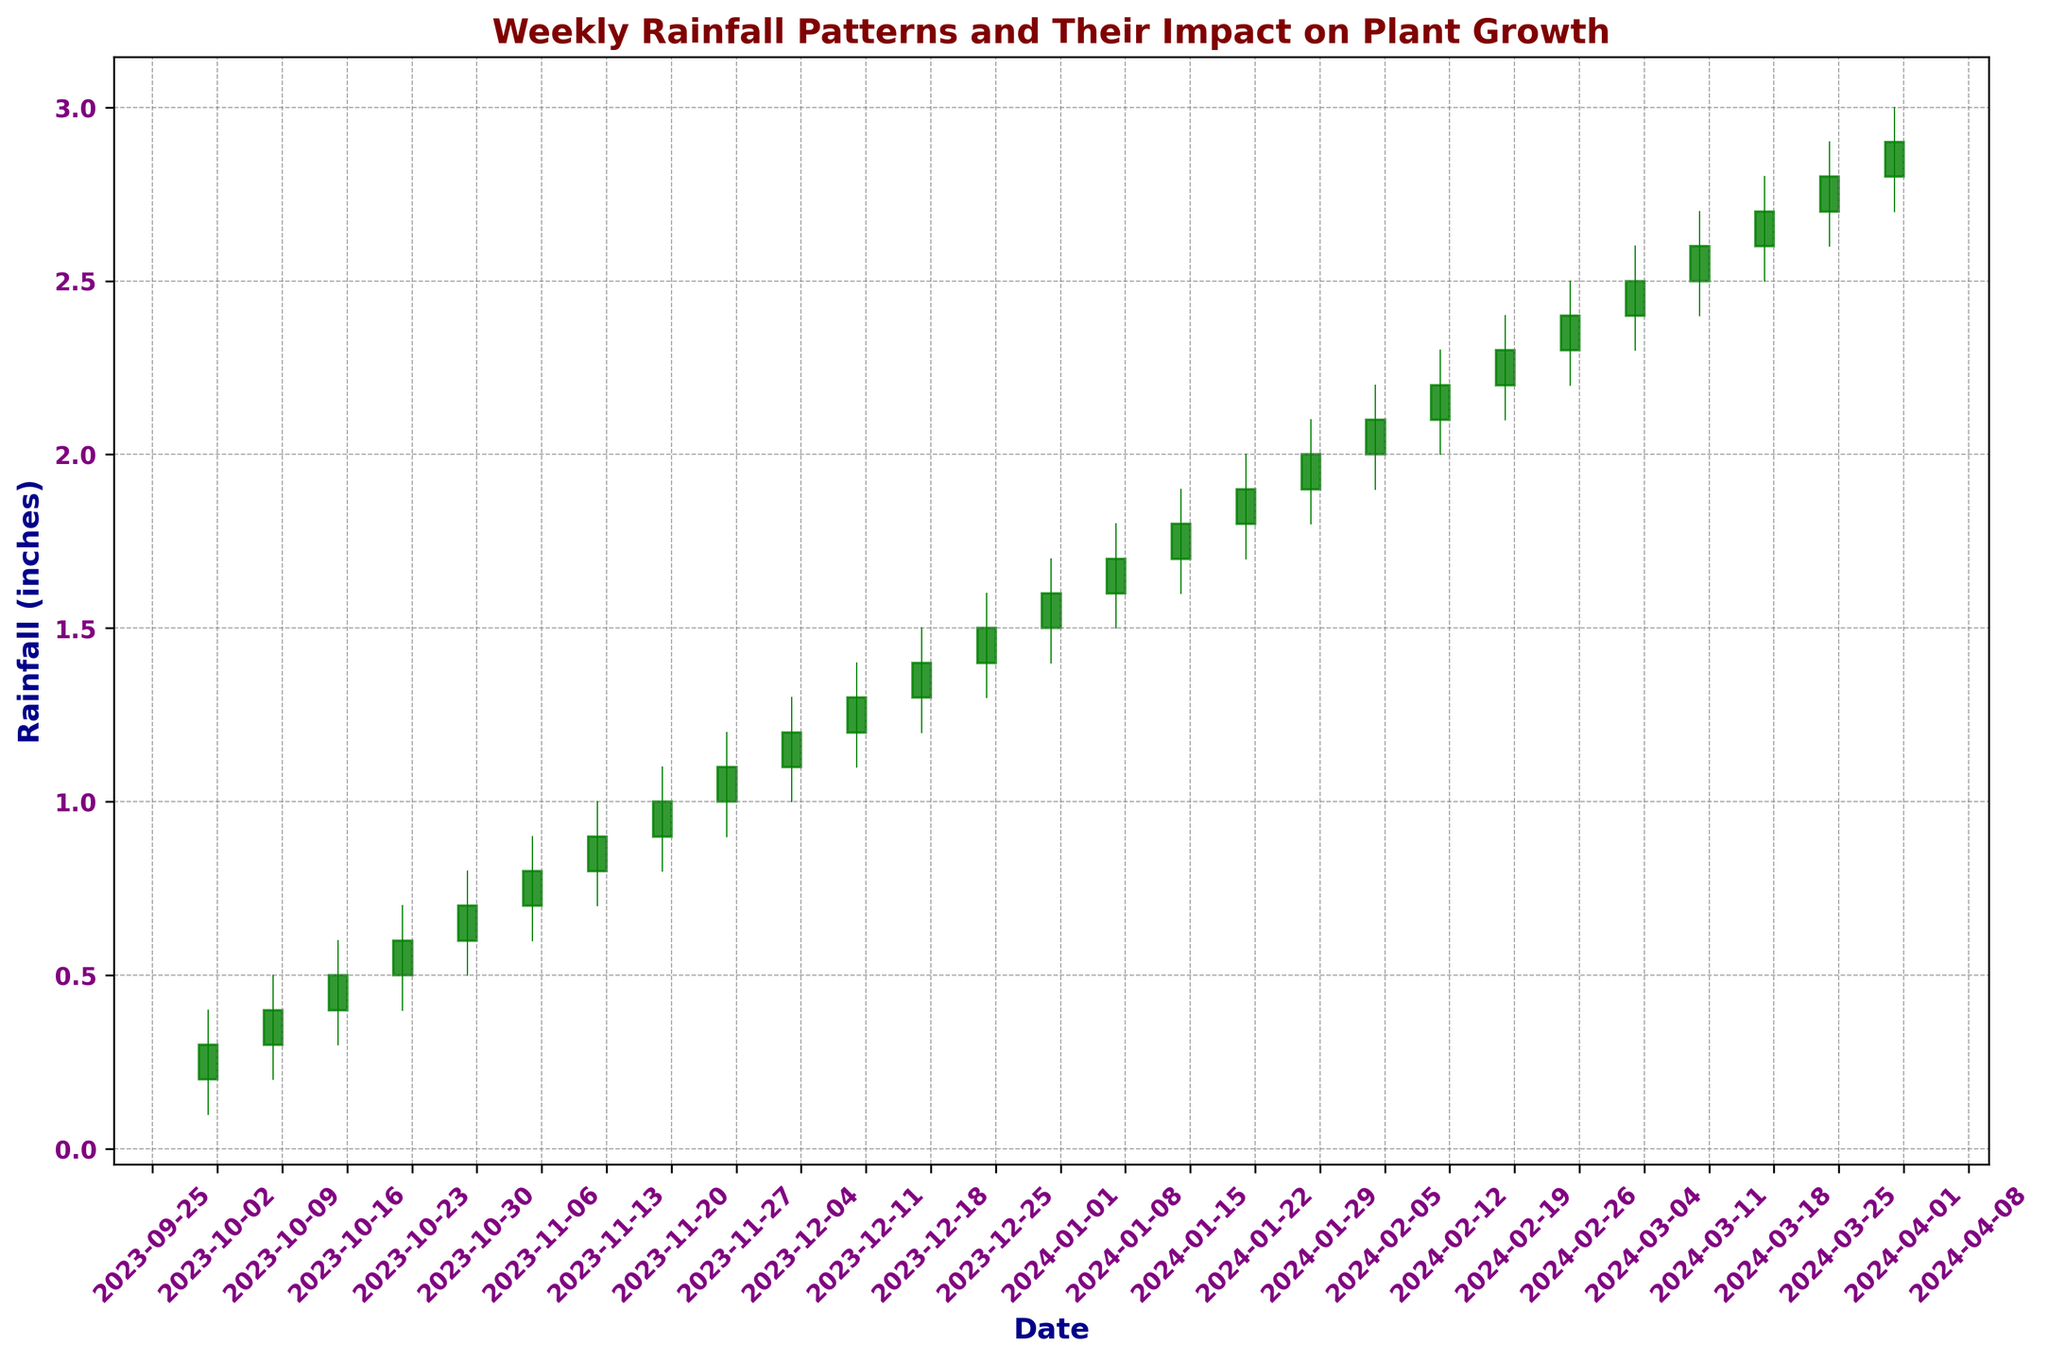How much rainfall was observed in the highest rainfall week, and when did it occur? Look at the 'High' values on the candlestick chart. The highest value is 2.9 inches, which corresponds to the week ending on March 31, 2024.
Answer: 2.9 inches on March 31, 2024 What is the average rainfall of the weeks with the lowest 'Low' values from October to December? Identify the 'Low' values from October to December. The values are 0.1, 0.2, 0.3, 0.4, 0.5, 0.6, 0.7, 0.8, 0.9, 1.0, 1.1, 1.2, 1.3, and 1.4 inches. The sum is 11.3 inches, and the average is 11.3/14 weeks = 0.8071 inches.
Answer: 0.8071 inches Which week had the smallest difference between the 'High' and 'Low' rainfall? Calculate the difference between 'High' and 'Low' values for each week. Look for the smallest difference. For instance, on February 18, 2024, the difference is 2.4 - 2.1 = 0.3 inches, which is the smallest.
Answer: February 18, 2024 Was there a continuous increase in rainfall in any four-week period? Analyze the 'Close' values for continuous increments over any four-week period. For example, from November 5, 2023 (0.8 inches) to November 26, 2023 (1.1 inches), the values are continuously increasing each week.
Answer: Yes, November 5-26, 2023 How does the highest 'Close' value in October compare with the highest 'Close' value in January? Identify the highest 'Close' values in October and January. In October, the highest 'Close' is 0.7 inches, and in January, it's 1.8 inches. January's highest 'Close' is greater.
Answer: January's highest 'Close' is greater What was the 'Close' value on the week of November 26, 2023, and how does it compare to the previous week? Look at the 'Close' value for November 26, 2023, which is 1.1 inches. The previous week (November 19, 2023) had a 'Close' of 1.0 inches. The 'Close' increased by 0.1 inches.
Answer: 1.1 inches, increased by 0.1 inches Among the weeks from January 2024, which week had the highest 'Open' rainfall? Identify the 'Open' values for weeks in January 2024. The highest 'Open' value is 1.6 inches on the week of January 28, 2024.
Answer: January 28, 2024 Which week experienced the lowest 'Low' rainfall from January to March 2024? Look at the 'Low' values from January to March 2024. The lowest 'Low' value is 1.5 inches on the week of January 7, 2024.
Answer: January 7, 2024 What is the total rainfall for the first and last weeks of the data set? Sum the 'Close' values of the first week (0.3 inches on October 1, 2023) and the last week (2.9 inches on March 31, 2024). The total is 0.3 + 2.9 = 3.2 inches.
Answer: 3.2 inches 